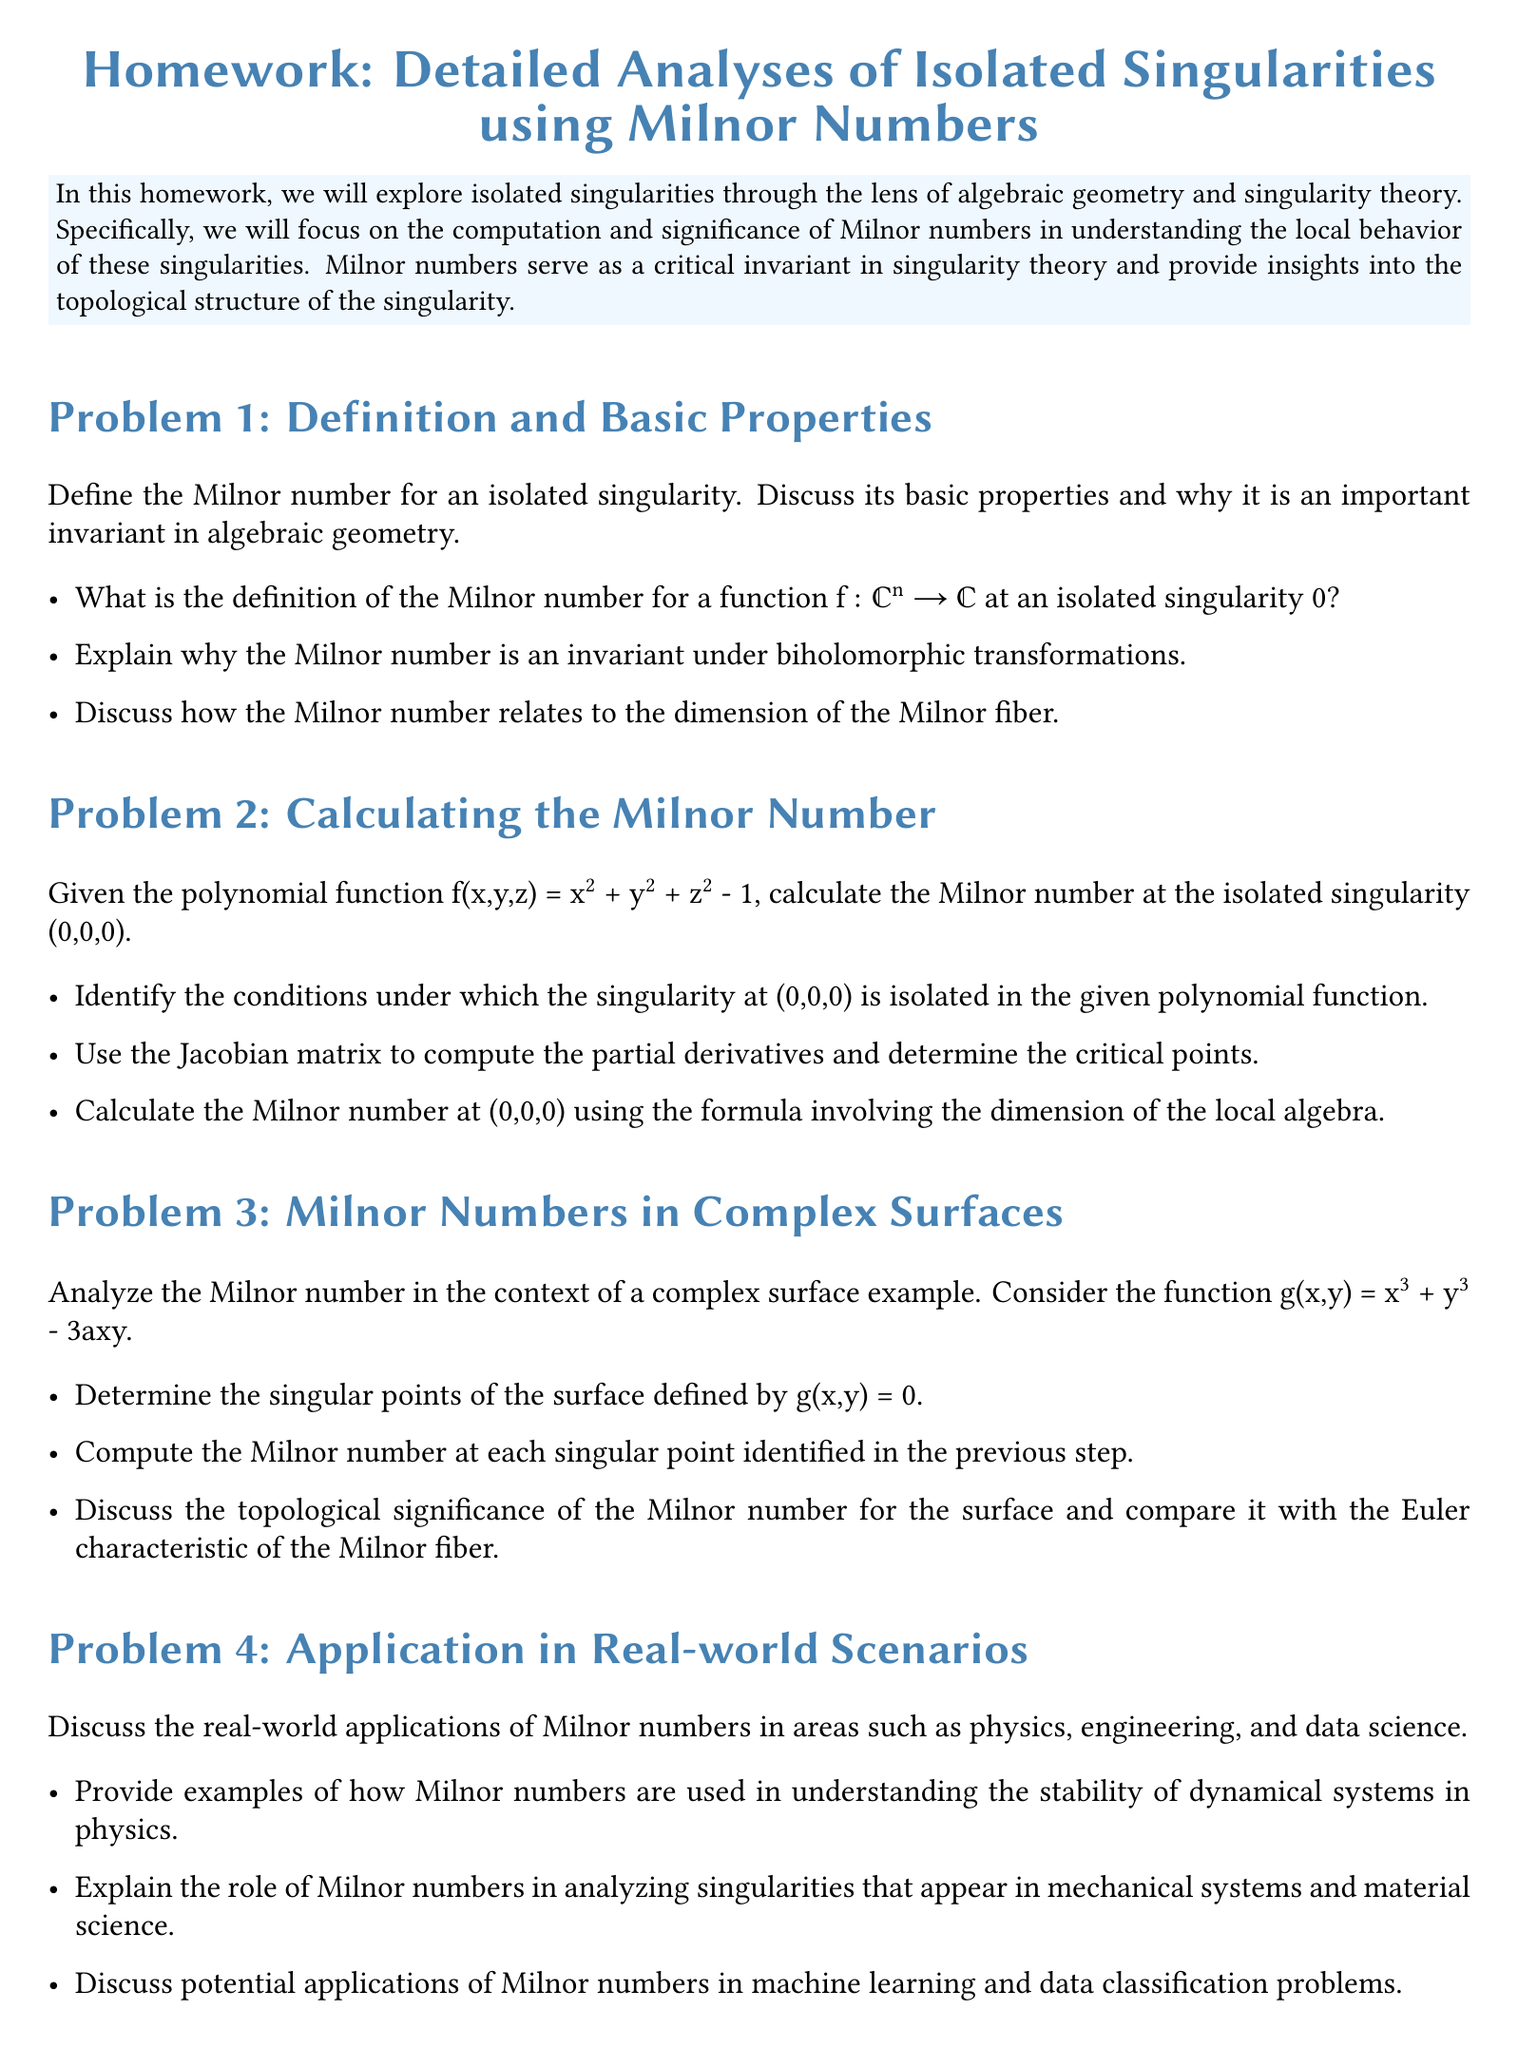What is the title of the homework? The title is given at the center of the document, indicating the subject of the homework.
Answer: Homework: Detailed Analyses of Isolated Singularities using Milnor Numbers What is the primary focus of this homework? The focus is specified in the introduction of the homework document, detailing the area of study.
Answer: Isolated singularities and Milnor numbers What is the first problem in the homework? The list of problems starts immediately after the introduction, with the first one clearly stated.
Answer: Problem 1: Definition and Basic Properties What polynomial function is mentioned in Problem 2? The specific polynomial function is explicitly stated in Problem 2 as part of the calculation task.
Answer: f(x,y,z) = x² + y² + z² - 1 Who is the author of the reference titled "Singular Points of Complex Hypersurfaces"? The references section lists various authors and their works related to the study of singularities.
Answer: John Milnor What is the second problem related to? The nature of the second problem is identified in the header for that section, indicating its focus.
Answer: Calculating the Milnor Number How many items are there in the references section? The references section lists the number of works cited, which pertains to the document's literature.
Answer: Three What is the significance of the Milnor number discussed in Problem 3? The importance of the Milnor number is highlighted in the context of algebraic structures and topology in Problem 3.
Answer: Topological significance What does the function g(x,y) in Problem 3 equal? The function g is specifically stated in the problem statement as part of its analysis.
Answer: g(x,y) = x³ + y³ - 3axy What application area is mentioned for Milnor numbers in Problem 4? Problem 4 discusses various fields where Milnor numbers have implications, indicating their use.
Answer: Physics, engineering, data science 